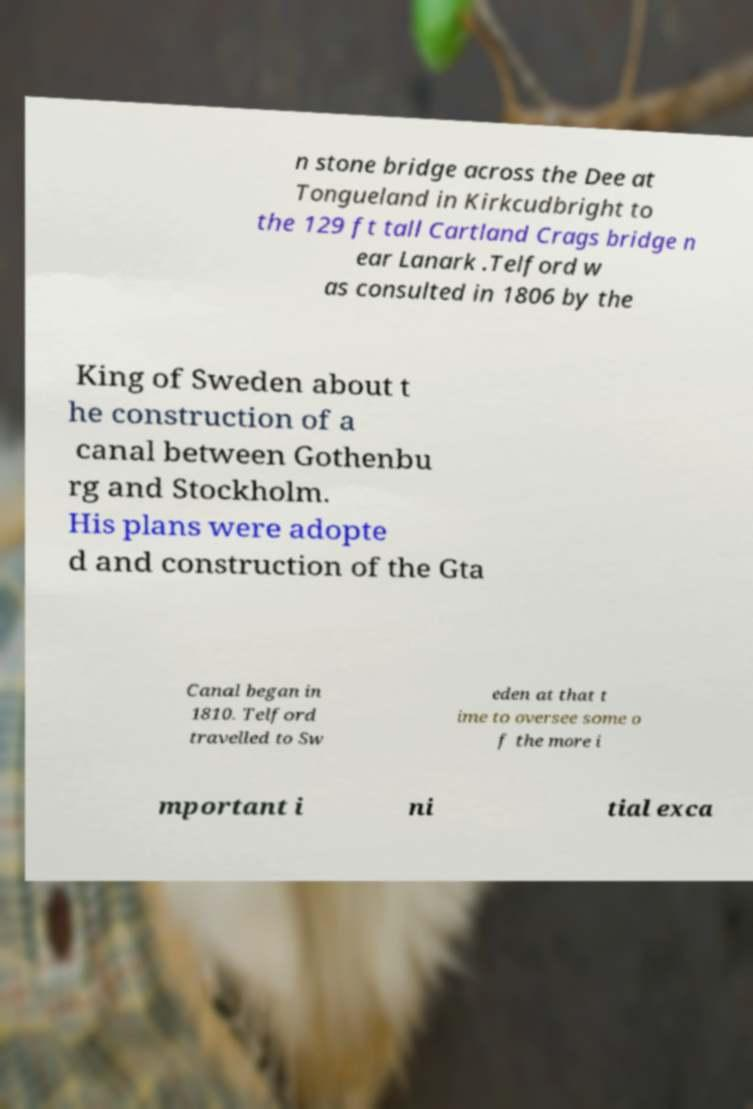What messages or text are displayed in this image? I need them in a readable, typed format. n stone bridge across the Dee at Tongueland in Kirkcudbright to the 129 ft tall Cartland Crags bridge n ear Lanark .Telford w as consulted in 1806 by the King of Sweden about t he construction of a canal between Gothenbu rg and Stockholm. His plans were adopte d and construction of the Gta Canal began in 1810. Telford travelled to Sw eden at that t ime to oversee some o f the more i mportant i ni tial exca 